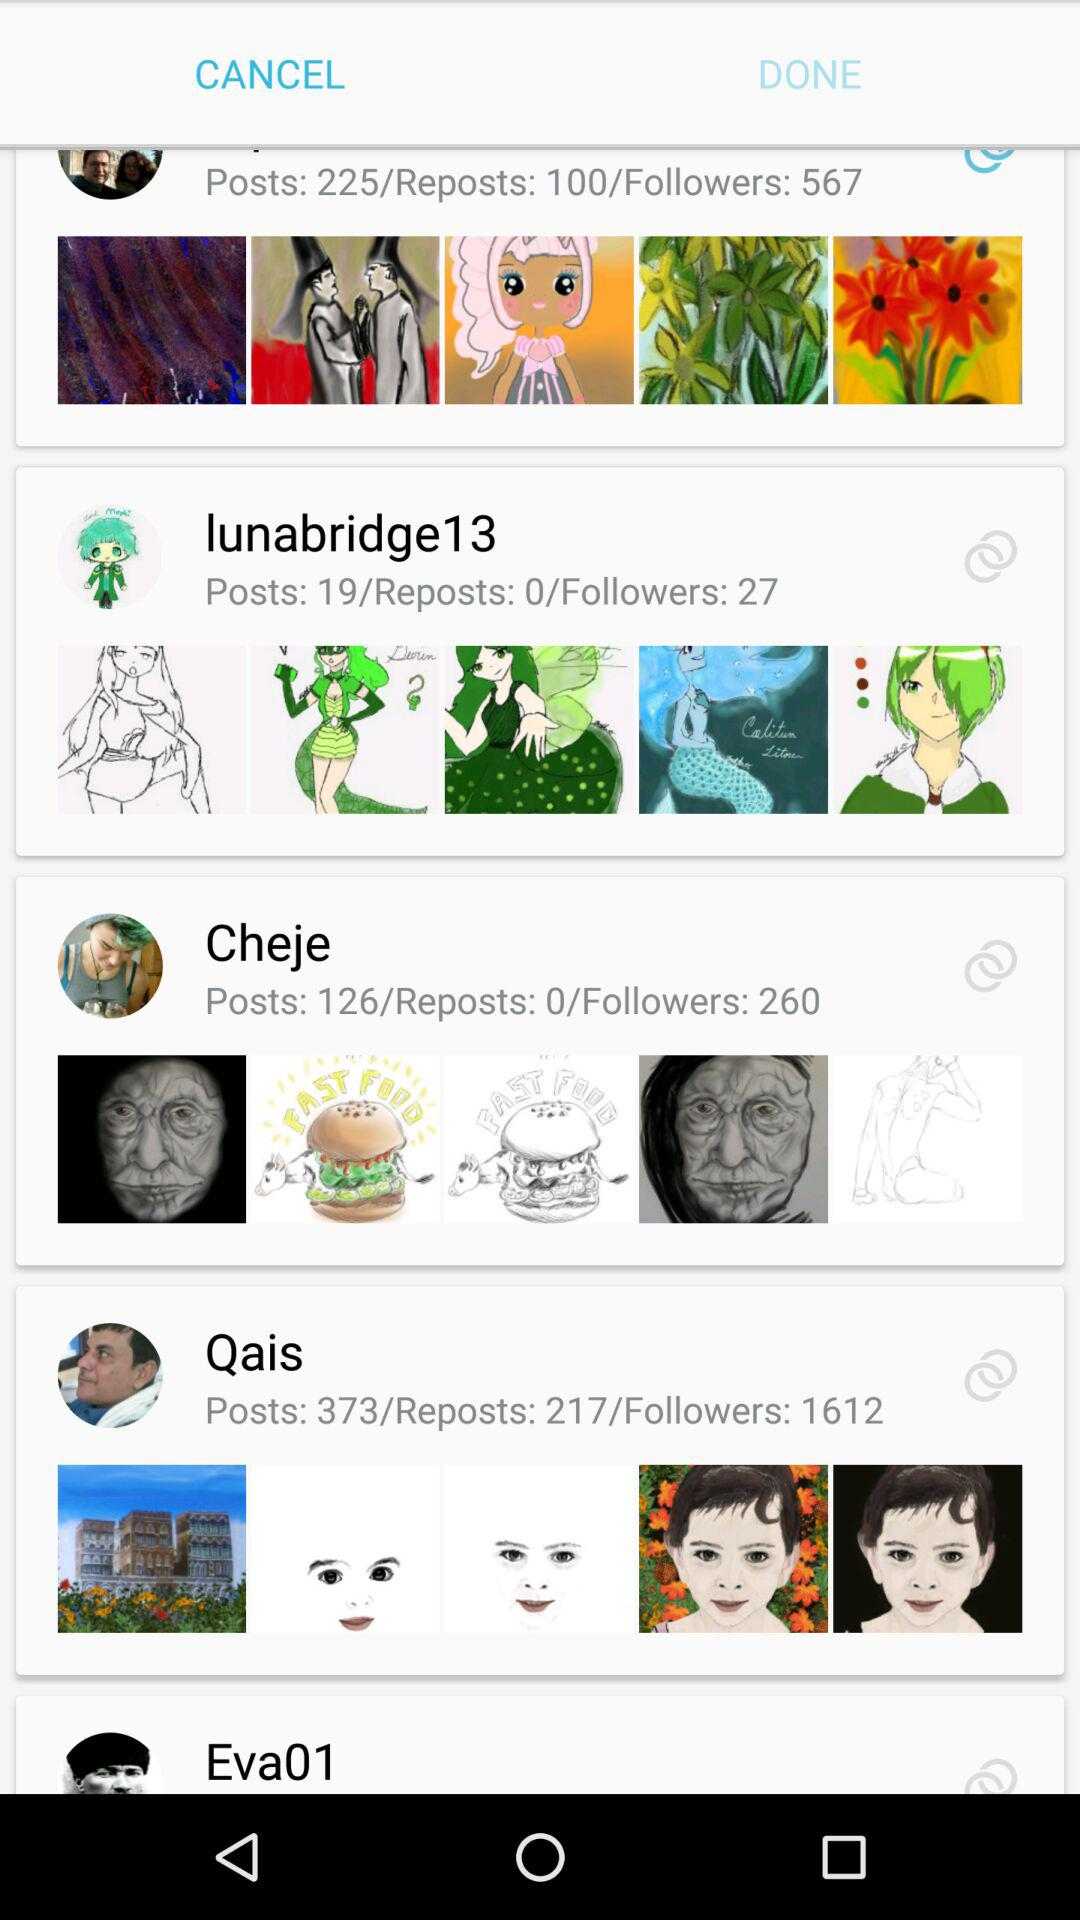How many posts in "Qais"? There are 373 posts in "Qais". 